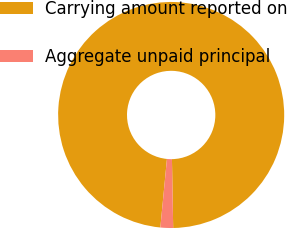<chart> <loc_0><loc_0><loc_500><loc_500><pie_chart><fcel>Carrying amount reported on<fcel>Aggregate unpaid principal<nl><fcel>98.19%<fcel>1.81%<nl></chart> 